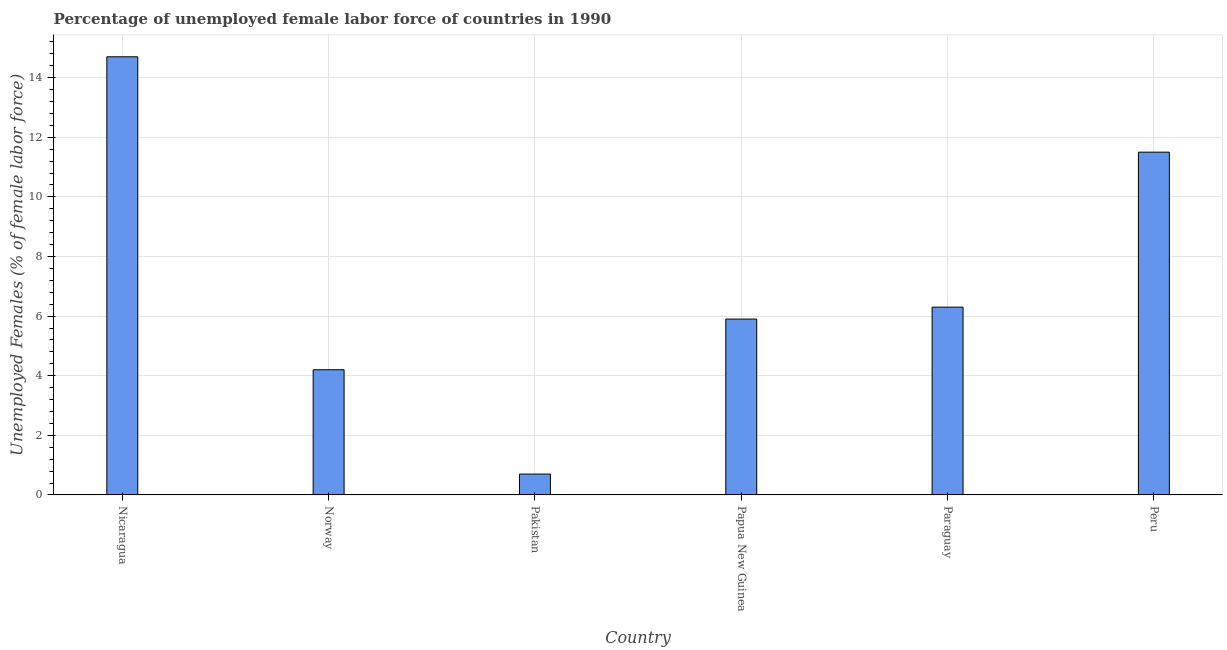What is the title of the graph?
Ensure brevity in your answer.  Percentage of unemployed female labor force of countries in 1990. What is the label or title of the Y-axis?
Make the answer very short. Unemployed Females (% of female labor force). What is the total unemployed female labour force in Papua New Guinea?
Your answer should be compact. 5.9. Across all countries, what is the maximum total unemployed female labour force?
Give a very brief answer. 14.7. Across all countries, what is the minimum total unemployed female labour force?
Offer a very short reply. 0.7. In which country was the total unemployed female labour force maximum?
Your answer should be compact. Nicaragua. In which country was the total unemployed female labour force minimum?
Provide a succinct answer. Pakistan. What is the sum of the total unemployed female labour force?
Provide a short and direct response. 43.3. What is the difference between the total unemployed female labour force in Papua New Guinea and Paraguay?
Your answer should be compact. -0.4. What is the average total unemployed female labour force per country?
Your answer should be very brief. 7.22. What is the median total unemployed female labour force?
Make the answer very short. 6.1. In how many countries, is the total unemployed female labour force greater than 4 %?
Ensure brevity in your answer.  5. What is the ratio of the total unemployed female labour force in Norway to that in Paraguay?
Ensure brevity in your answer.  0.67. Is the total unemployed female labour force in Paraguay less than that in Peru?
Keep it short and to the point. Yes. Is the sum of the total unemployed female labour force in Pakistan and Papua New Guinea greater than the maximum total unemployed female labour force across all countries?
Make the answer very short. No. How many bars are there?
Offer a very short reply. 6. Are the values on the major ticks of Y-axis written in scientific E-notation?
Give a very brief answer. No. What is the Unemployed Females (% of female labor force) in Nicaragua?
Offer a very short reply. 14.7. What is the Unemployed Females (% of female labor force) in Norway?
Offer a very short reply. 4.2. What is the Unemployed Females (% of female labor force) in Pakistan?
Your answer should be very brief. 0.7. What is the Unemployed Females (% of female labor force) in Papua New Guinea?
Your answer should be compact. 5.9. What is the Unemployed Females (% of female labor force) of Paraguay?
Offer a very short reply. 6.3. What is the Unemployed Females (% of female labor force) of Peru?
Your response must be concise. 11.5. What is the difference between the Unemployed Females (% of female labor force) in Nicaragua and Norway?
Keep it short and to the point. 10.5. What is the difference between the Unemployed Females (% of female labor force) in Nicaragua and Papua New Guinea?
Give a very brief answer. 8.8. What is the difference between the Unemployed Females (% of female labor force) in Nicaragua and Paraguay?
Ensure brevity in your answer.  8.4. What is the difference between the Unemployed Females (% of female labor force) in Nicaragua and Peru?
Your answer should be compact. 3.2. What is the difference between the Unemployed Females (% of female labor force) in Norway and Pakistan?
Offer a very short reply. 3.5. What is the difference between the Unemployed Females (% of female labor force) in Norway and Paraguay?
Your answer should be very brief. -2.1. What is the difference between the Unemployed Females (% of female labor force) in Norway and Peru?
Ensure brevity in your answer.  -7.3. What is the difference between the Unemployed Females (% of female labor force) in Pakistan and Papua New Guinea?
Give a very brief answer. -5.2. What is the difference between the Unemployed Females (% of female labor force) in Papua New Guinea and Paraguay?
Provide a short and direct response. -0.4. What is the difference between the Unemployed Females (% of female labor force) in Papua New Guinea and Peru?
Provide a short and direct response. -5.6. What is the difference between the Unemployed Females (% of female labor force) in Paraguay and Peru?
Offer a very short reply. -5.2. What is the ratio of the Unemployed Females (% of female labor force) in Nicaragua to that in Norway?
Make the answer very short. 3.5. What is the ratio of the Unemployed Females (% of female labor force) in Nicaragua to that in Pakistan?
Keep it short and to the point. 21. What is the ratio of the Unemployed Females (% of female labor force) in Nicaragua to that in Papua New Guinea?
Your answer should be very brief. 2.49. What is the ratio of the Unemployed Females (% of female labor force) in Nicaragua to that in Paraguay?
Provide a short and direct response. 2.33. What is the ratio of the Unemployed Females (% of female labor force) in Nicaragua to that in Peru?
Offer a very short reply. 1.28. What is the ratio of the Unemployed Females (% of female labor force) in Norway to that in Papua New Guinea?
Ensure brevity in your answer.  0.71. What is the ratio of the Unemployed Females (% of female labor force) in Norway to that in Paraguay?
Give a very brief answer. 0.67. What is the ratio of the Unemployed Females (% of female labor force) in Norway to that in Peru?
Offer a very short reply. 0.36. What is the ratio of the Unemployed Females (% of female labor force) in Pakistan to that in Papua New Guinea?
Your answer should be very brief. 0.12. What is the ratio of the Unemployed Females (% of female labor force) in Pakistan to that in Paraguay?
Your answer should be compact. 0.11. What is the ratio of the Unemployed Females (% of female labor force) in Pakistan to that in Peru?
Your response must be concise. 0.06. What is the ratio of the Unemployed Females (% of female labor force) in Papua New Guinea to that in Paraguay?
Offer a terse response. 0.94. What is the ratio of the Unemployed Females (% of female labor force) in Papua New Guinea to that in Peru?
Make the answer very short. 0.51. What is the ratio of the Unemployed Females (% of female labor force) in Paraguay to that in Peru?
Ensure brevity in your answer.  0.55. 